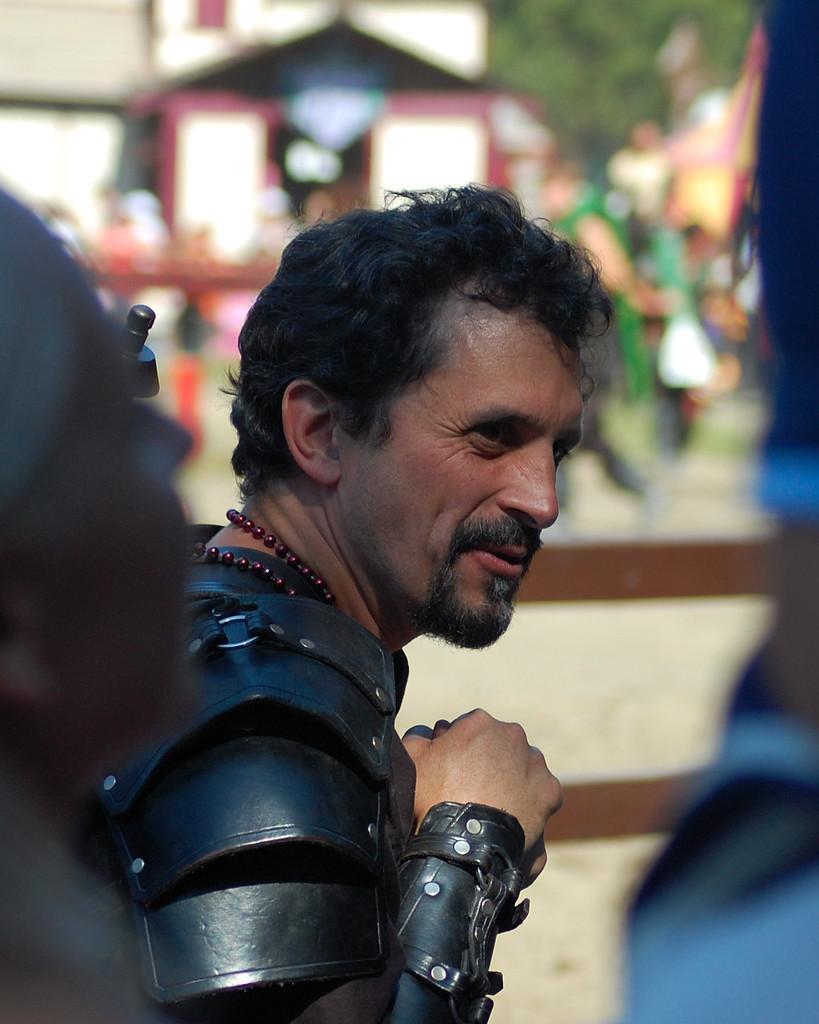In one or two sentences, can you explain what this image depicts? In the center of the picture there is a man. In the foreground it is blurred. The background is blurred, in the background there are people, buildings and trees. 